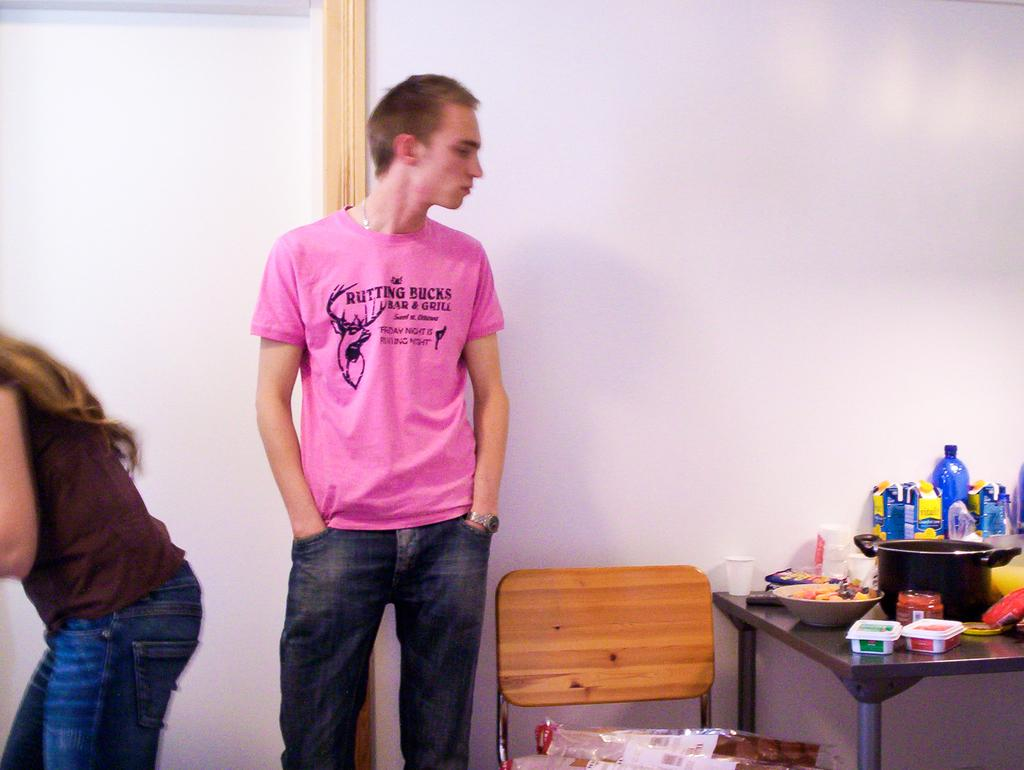What is the man in the image wearing? The man is wearing a blue shirt in the image. What is the man's posture in the image? The man is standing in the image. Who is sitting beside the man? There is a woman sitting beside the man in the image. What can be seen in the background of the image? There is a chair and a table in the background of the image. What is placed on the table in the image? Food items are placed on the table in the image. How many passengers are visible in the image? There is no reference to passengers in the image; it only features a man and a woman. What type of operation is being performed on the table in the image? There is no operation being performed on the table in the image; it is simply a table with food items placed on it. 